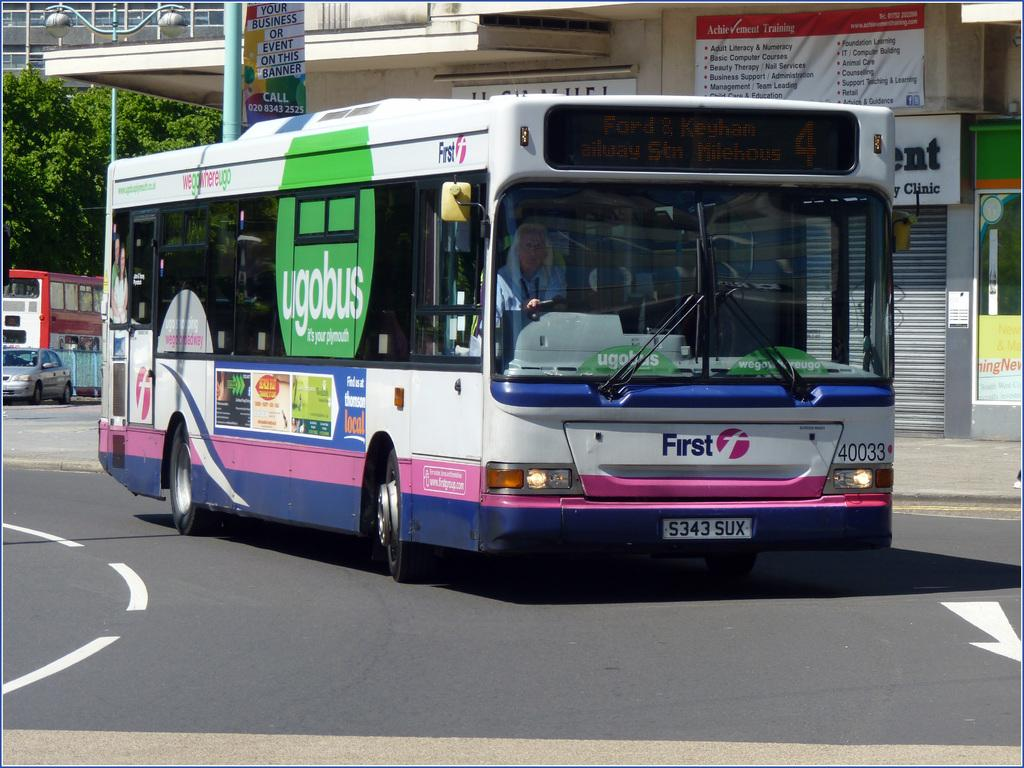<image>
Offer a succinct explanation of the picture presented. A bus on a street with the word First below the windshield. 